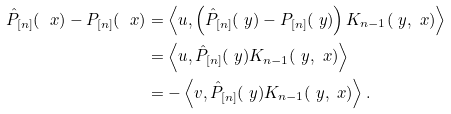Convert formula to latex. <formula><loc_0><loc_0><loc_500><loc_500>\hat { P } _ { [ n ] } ( \ x ) - P _ { [ n ] } ( \ x ) & = \left \langle u , \left ( \hat { P } _ { [ n ] } ( \ y ) - P _ { [ n ] } ( \ y ) \right ) K _ { n - 1 } ( \ y , \ x ) \right \rangle \\ & = \left \langle u , \hat { P } _ { [ n ] } ( \ y ) K _ { n - 1 } ( \ y , \ x ) \right \rangle \\ & = - \left \langle v , \hat { P } _ { [ n ] } ( \ y ) K _ { n - 1 } ( \ y , \ x ) \right \rangle .</formula> 